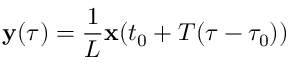Convert formula to latex. <formula><loc_0><loc_0><loc_500><loc_500>{ \mathbf y } ( \tau ) = \frac { 1 } { L } { \mathbf x } ( t _ { 0 } + T ( \tau - \tau _ { 0 } ) )</formula> 